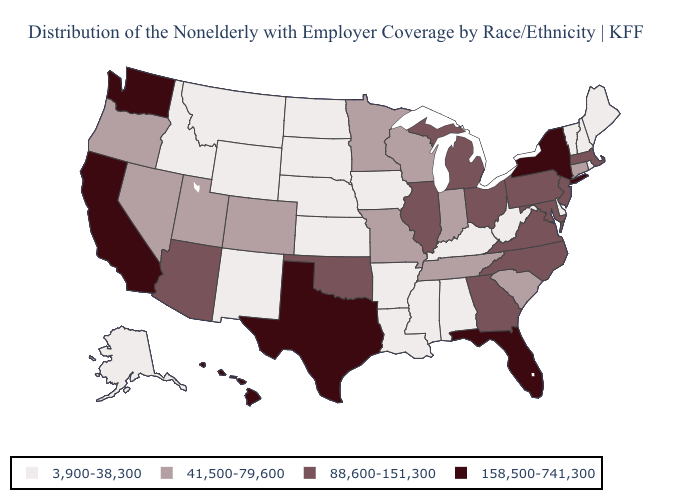What is the value of Washington?
Write a very short answer. 158,500-741,300. Among the states that border Ohio , which have the highest value?
Quick response, please. Michigan, Pennsylvania. Which states have the lowest value in the USA?
Quick response, please. Alabama, Alaska, Arkansas, Delaware, Idaho, Iowa, Kansas, Kentucky, Louisiana, Maine, Mississippi, Montana, Nebraska, New Hampshire, New Mexico, North Dakota, Rhode Island, South Dakota, Vermont, West Virginia, Wyoming. Does Texas have the highest value in the USA?
Concise answer only. Yes. Name the states that have a value in the range 158,500-741,300?
Give a very brief answer. California, Florida, Hawaii, New York, Texas, Washington. What is the value of Arizona?
Answer briefly. 88,600-151,300. What is the lowest value in the Northeast?
Quick response, please. 3,900-38,300. Which states have the highest value in the USA?
Write a very short answer. California, Florida, Hawaii, New York, Texas, Washington. Among the states that border Utah , which have the highest value?
Answer briefly. Arizona. What is the value of New Jersey?
Give a very brief answer. 88,600-151,300. Which states have the highest value in the USA?
Be succinct. California, Florida, Hawaii, New York, Texas, Washington. What is the value of Idaho?
Quick response, please. 3,900-38,300. Does the first symbol in the legend represent the smallest category?
Be succinct. Yes. What is the value of Virginia?
Write a very short answer. 88,600-151,300. What is the highest value in the USA?
Keep it brief. 158,500-741,300. 